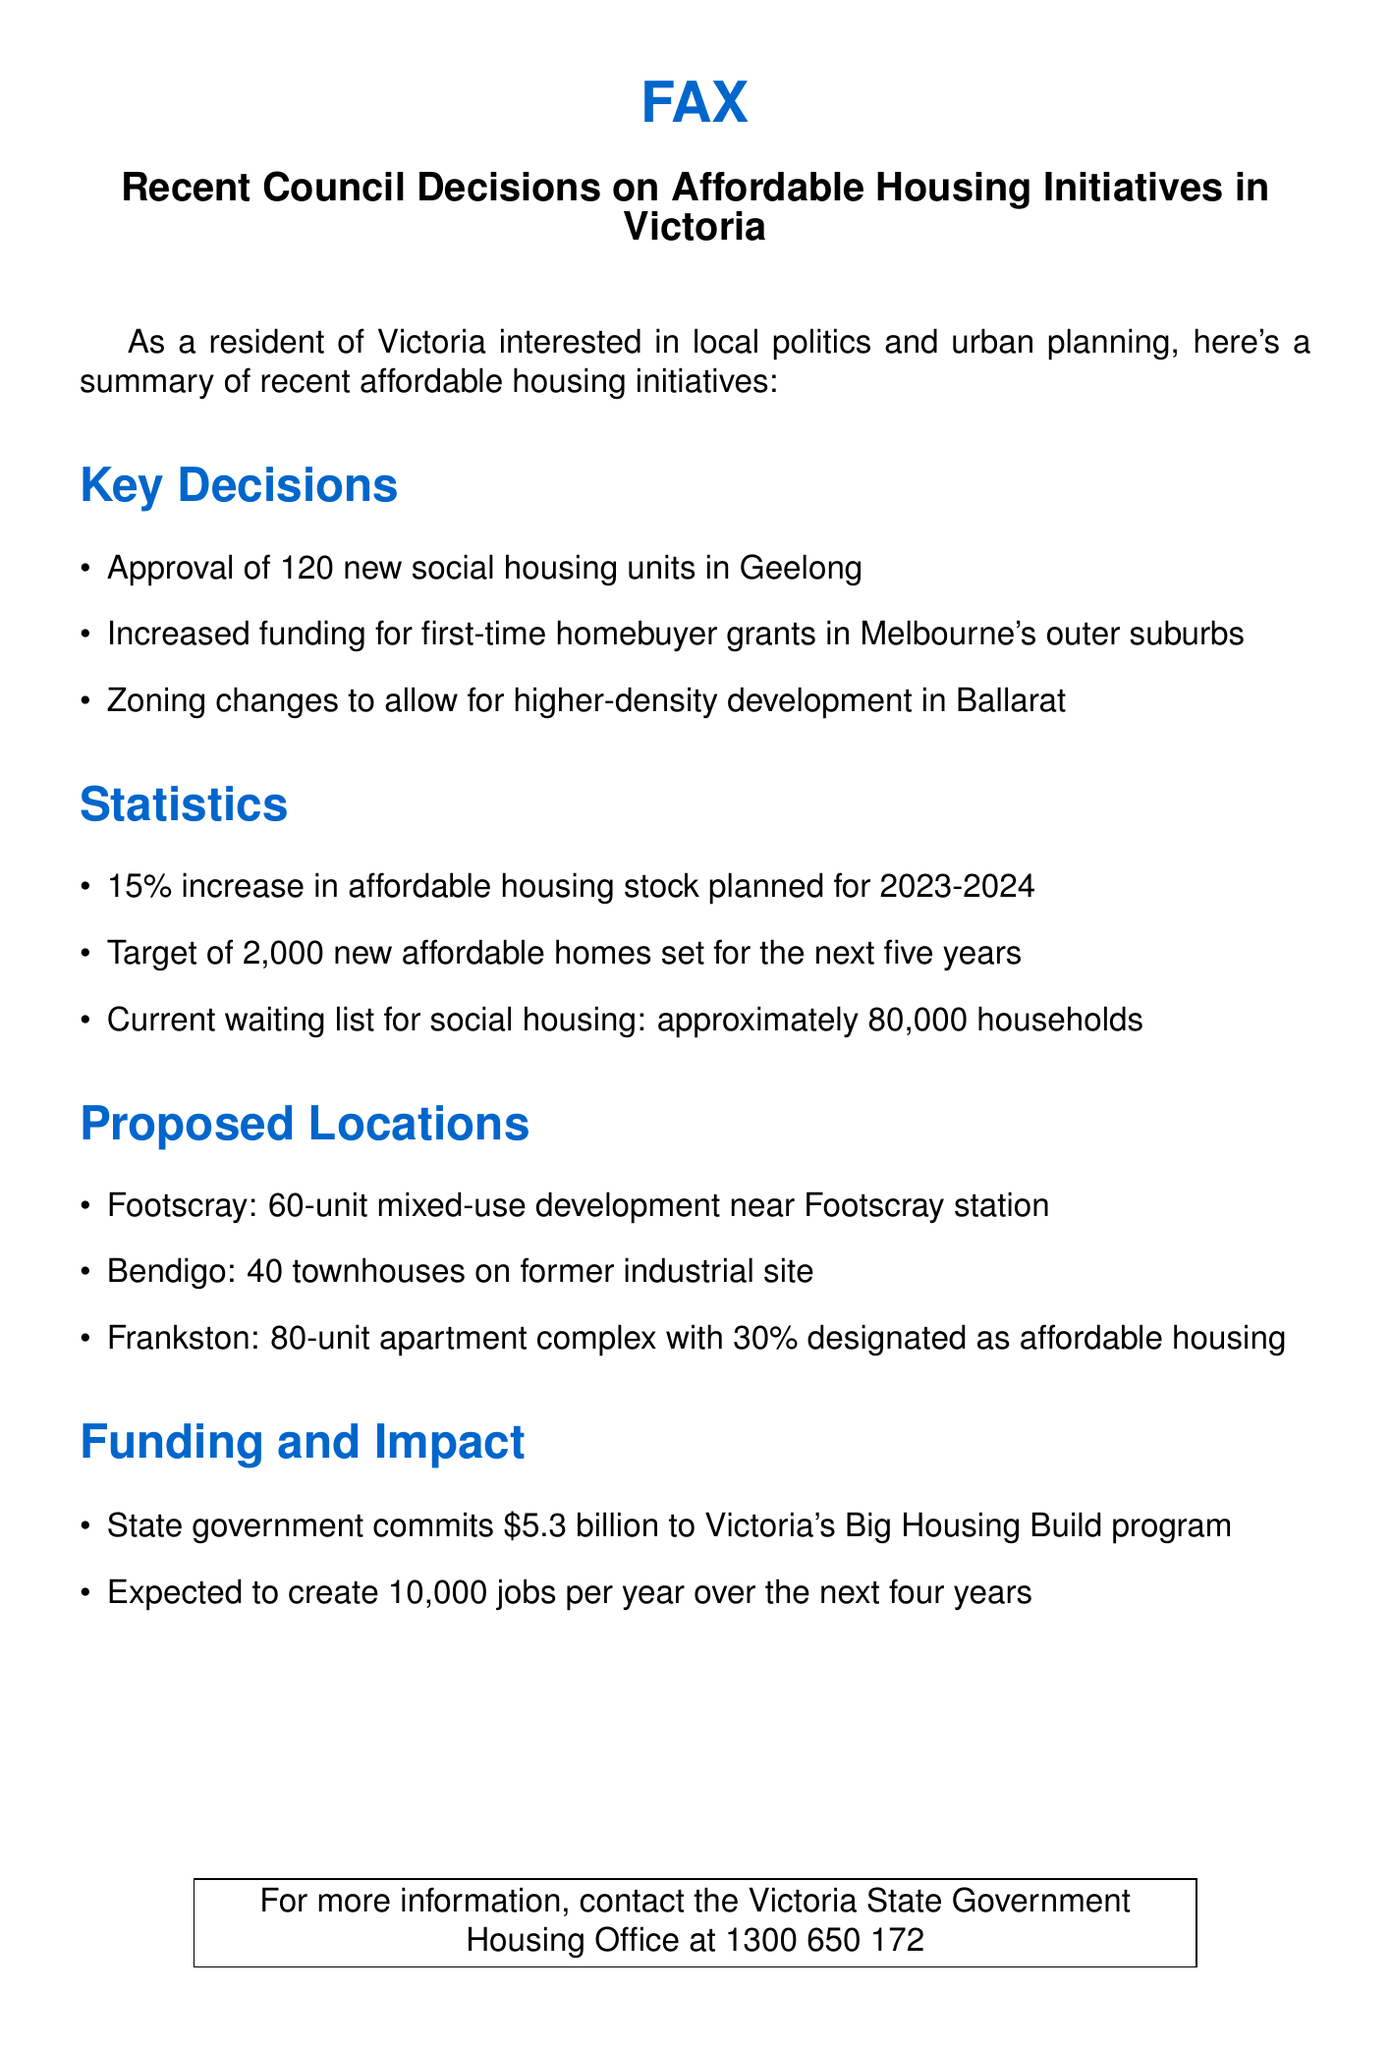What is the total number of new social housing units approved in Geelong? The document states that 120 new social housing units have been approved in Geelong.
Answer: 120 What percentage of the new apartment complex in Frankston is designated as affordable housing? The document indicates that 30% of the new apartment complex in Frankston is designated as affordable housing.
Answer: 30% How much funding has the state government committed to the Big Housing Build program? The document mentions that the state government has committed $5.3 billion to the Big Housing Build program.
Answer: $5.3 billion What is the target for new affordable homes set for the next five years? According to the document, the target for new affordable homes set for the next five years is 2,000 homes.
Answer: 2,000 What is the current waiting list for social housing? The document states that the current waiting list for social housing is approximately 80,000 households.
Answer: Approximately 80,000 households What is the expected job creation per year from the housing initiatives? The document notes that the initiatives are expected to create 10,000 jobs per year over the next four years.
Answer: 10,000 jobs Which city is planning a 60-unit mixed-use development near the station? The document specifies that Footscray is planning a 60-unit mixed-use development near Footscray station.
Answer: Footscray Why were zoning changes made in Ballarat? Zoning changes were made in Ballarat to allow for higher-density development, as noted in the document.
Answer: Higher-density development Where are 40 townhouses planned on a former industrial site? The document indicates that Bendigo is planning 40 townhouses on a former industrial site.
Answer: Bendigo 